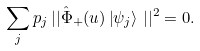<formula> <loc_0><loc_0><loc_500><loc_500>\sum _ { j } p _ { j } \, | | { \hat { \Phi } } _ { + } ( u ) \left | \psi _ { j } \right > \, | | ^ { 2 } = 0 .</formula> 